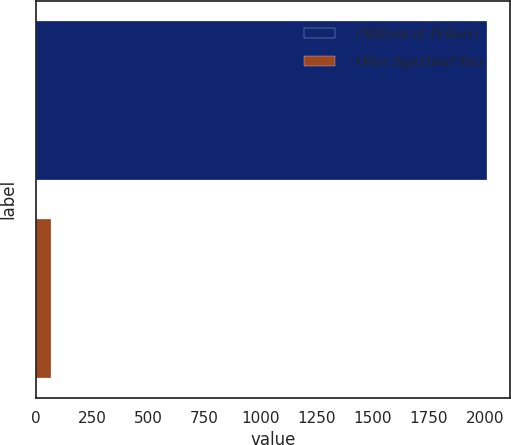Convert chart. <chart><loc_0><loc_0><loc_500><loc_500><bar_chart><fcel>(Millions of Dollars)<fcel>Other Superfund Sites<nl><fcel>2011<fcel>67<nl></chart> 